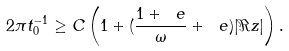<formula> <loc_0><loc_0><loc_500><loc_500>2 \pi t _ { 0 } ^ { - 1 } \geq C \left ( 1 + ( \frac { 1 + \ e } { \omega } + \ e ) | \Re z | \right ) .</formula> 